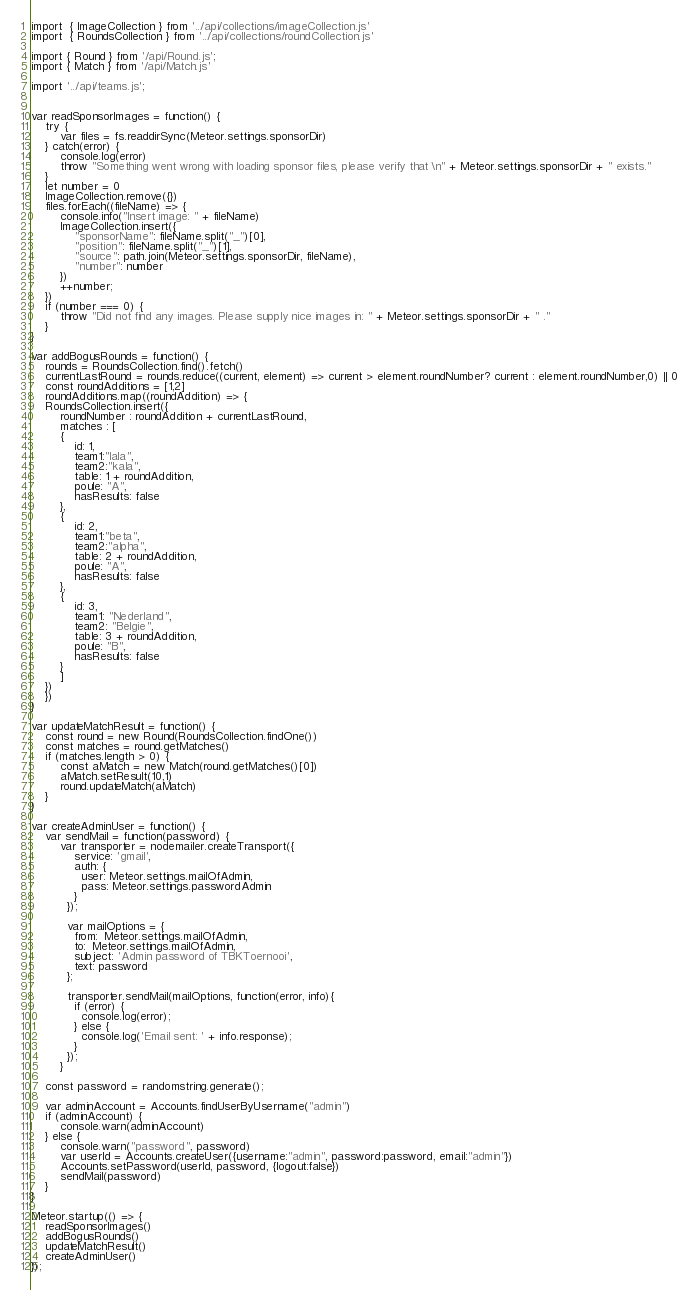<code> <loc_0><loc_0><loc_500><loc_500><_JavaScript_>import  { ImageCollection } from '../api/collections/imageCollection.js'
import  { RoundsCollection } from '../api/collections/roundCollection.js'

import { Round } from '/api/Round.js';
import { Match } from '/api/Match.js'

import '../api/teams.js';


var readSponsorImages = function() {
    try {
		var files = fs.readdirSync(Meteor.settings.sponsorDir)
    } catch(error) {
		console.log(error)
		throw "Something went wrong with loading sponsor files, please verify that \n" + Meteor.settings.sponsorDir + " exists." 
    }
    let number = 0
    ImageCollection.remove({})
    files.forEach((fileName) => {
		console.info("Insert image: " + fileName)
		ImageCollection.insert({
			"sponsorName": fileName.split("_")[0],
			"position": fileName.split("_")[1],
			"source": path.join(Meteor.settings.sponsorDir, fileName),
			"number": number
		})
		++number;
    })
    if (number === 0) {
		throw "Did not find any images. Please supply nice images in: " + Meteor.settings.sponsorDir + " ."
    }
} 

var addBogusRounds = function() {
	rounds = RoundsCollection.find().fetch()
    currentLastRound = rounds.reduce((current, element) => current > element.roundNumber? current : element.roundNumber,0) || 0
    const roundAdditions = [1,2]
    roundAdditions.map((roundAddition) => {
	RoundsCollection.insert({
	    roundNumber : roundAddition + currentLastRound,
	    matches : [
		{
			id: 1,
			team1:"lala",
		    team2:"kala",
		    table: 1 + roundAddition,
			poule: "A",
			hasResults: false
		},
		{
			id: 2,
		    team1:"beta",
		    team2:"alpha",
		    table: 2 + roundAddition,
			poule: "A",
			hasResults: false
		},
		{
			id: 3,
		    team1: "Nederland",
		    team2: "Belgie",
		    table: 3 + roundAddition,
			poule: "B",
			hasResults: false
		}
	    ]
	})		
	})
}

var updateMatchResult = function() {
	const round = new Round(RoundsCollection.findOne())
	const matches = round.getMatches()
	if (matches.length > 0) {
		const aMatch = new Match(round.getMatches()[0])
		aMatch.setResult(10,1) 
		round.updateMatch(aMatch)
	}
}

var createAdminUser = function() {
	var sendMail = function(password) {
		var transporter = nodemailer.createTransport({
			service: 'gmail',
			auth: {
			  user: Meteor.settings.mailOfAdmin,
			  pass: Meteor.settings.passwordAdmin
			}
		  });
	
		  var mailOptions = {
			from:  Meteor.settings.mailOfAdmin,
			to:  Meteor.settings.mailOfAdmin,
			subject: 'Admin password of TBKToernooi',
			text: password
		  };
	
		  transporter.sendMail(mailOptions, function(error, info){
			if (error) {
			  console.log(error);
			} else {
			  console.log('Email sent: ' + info.response);
			}
		  });
		}

	const password = randomstring.generate();

	var adminAccount = Accounts.findUserByUsername("admin")
	if (adminAccount) {
		console.warn(adminAccount)
	} else {
		console.warn("password", password)
		var userId = Accounts.createUser({username:"admin", password:password, email:"admin"})
		Accounts.setPassword(userId, password, {logout:false})
		sendMail(password) 
	}
}

Meteor.startup(() => {
	readSponsorImages()
	addBogusRounds()
	updateMatchResult()
	createAdminUser()
});
</code> 